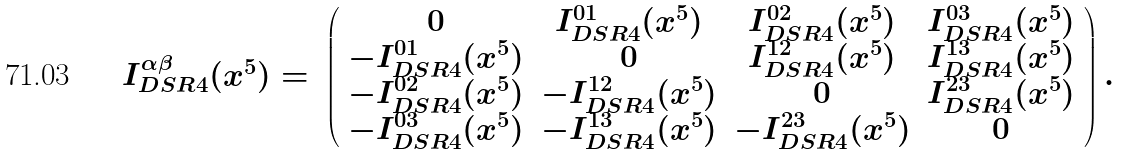Convert formula to latex. <formula><loc_0><loc_0><loc_500><loc_500>\begin{array} { c c } I _ { D S R 4 } ^ { \alpha \beta } ( x ^ { 5 } ) = & \left ( \begin{array} { c c c c } 0 & I _ { D S R 4 } ^ { 0 1 } ( x ^ { 5 } ) & I _ { D S R 4 } ^ { 0 2 } ( x ^ { 5 } ) & I _ { D S R 4 } ^ { 0 3 } ( x ^ { 5 } ) \\ - I _ { D S R 4 } ^ { 0 1 } ( x ^ { 5 } ) & 0 & I _ { D S R 4 } ^ { 1 2 } ( x ^ { 5 } ) & I _ { D S R 4 } ^ { 1 3 } ( x ^ { 5 } ) \\ - I _ { D S R 4 } ^ { 0 2 } ( x ^ { 5 } ) & - I _ { D S R 4 } ^ { 1 2 } ( x ^ { 5 } ) & 0 & I _ { D S R 4 } ^ { 2 3 } ( x ^ { 5 } ) \\ - I _ { D S R 4 } ^ { 0 3 } ( x ^ { 5 } ) & - I _ { D S R 4 } ^ { 1 3 } ( x ^ { 5 } ) & - I _ { D S R 4 } ^ { 2 3 } ( x ^ { 5 } ) & 0 \end{array} \right ) . \end{array}</formula> 